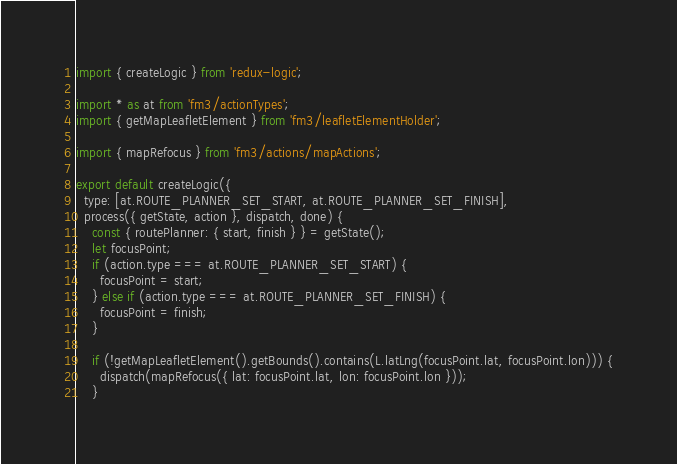Convert code to text. <code><loc_0><loc_0><loc_500><loc_500><_JavaScript_>import { createLogic } from 'redux-logic';

import * as at from 'fm3/actionTypes';
import { getMapLeafletElement } from 'fm3/leafletElementHolder';

import { mapRefocus } from 'fm3/actions/mapActions';

export default createLogic({
  type: [at.ROUTE_PLANNER_SET_START, at.ROUTE_PLANNER_SET_FINISH],
  process({ getState, action }, dispatch, done) {
    const { routePlanner: { start, finish } } = getState();
    let focusPoint;
    if (action.type === at.ROUTE_PLANNER_SET_START) {
      focusPoint = start;
    } else if (action.type === at.ROUTE_PLANNER_SET_FINISH) {
      focusPoint = finish;
    }

    if (!getMapLeafletElement().getBounds().contains(L.latLng(focusPoint.lat, focusPoint.lon))) {
      dispatch(mapRefocus({ lat: focusPoint.lat, lon: focusPoint.lon }));
    }
</code> 